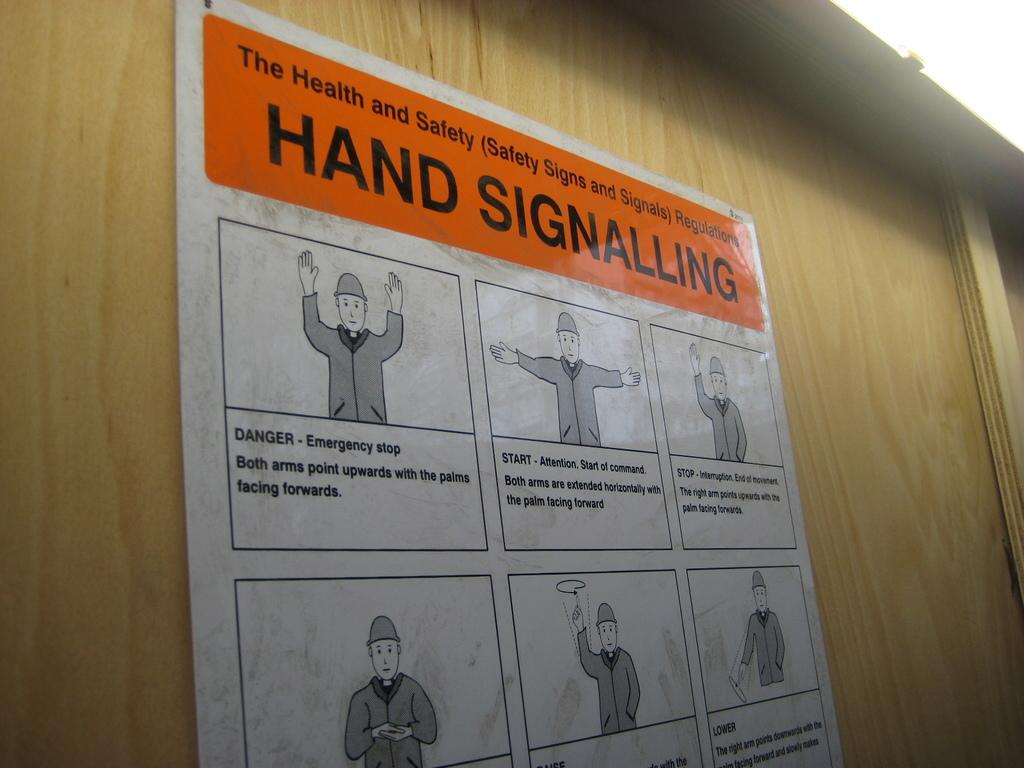<image>
Present a compact description of the photo's key features. Sign that shows health and safety hand signalling 